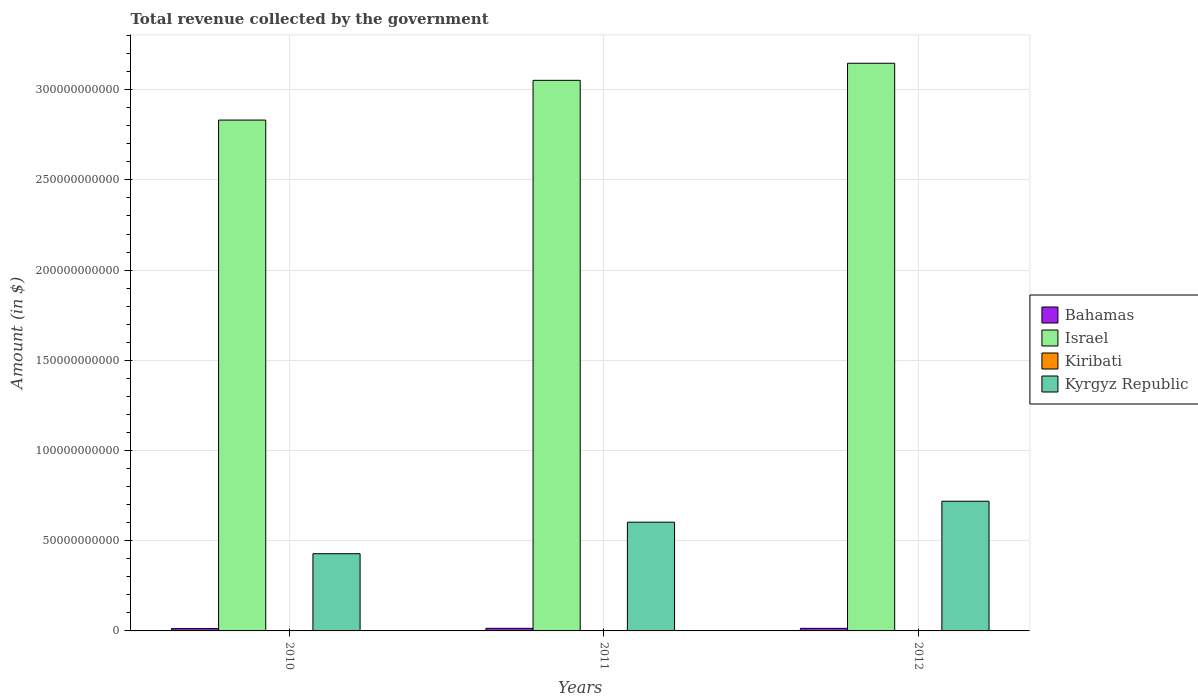How many different coloured bars are there?
Your answer should be compact. 4. Are the number of bars on each tick of the X-axis equal?
Provide a succinct answer. Yes. How many bars are there on the 3rd tick from the right?
Your response must be concise. 4. What is the label of the 1st group of bars from the left?
Your answer should be compact. 2010. In how many cases, is the number of bars for a given year not equal to the number of legend labels?
Offer a very short reply. 0. What is the total revenue collected by the government in Israel in 2010?
Ensure brevity in your answer.  2.83e+11. Across all years, what is the maximum total revenue collected by the government in Bahamas?
Provide a succinct answer. 1.43e+09. Across all years, what is the minimum total revenue collected by the government in Bahamas?
Keep it short and to the point. 1.29e+09. What is the total total revenue collected by the government in Bahamas in the graph?
Offer a terse response. 4.15e+09. What is the difference between the total revenue collected by the government in Kyrgyz Republic in 2011 and that in 2012?
Provide a short and direct response. -1.16e+1. What is the difference between the total revenue collected by the government in Israel in 2011 and the total revenue collected by the government in Bahamas in 2012?
Give a very brief answer. 3.04e+11. What is the average total revenue collected by the government in Kiribati per year?
Ensure brevity in your answer.  9.79e+07. In the year 2010, what is the difference between the total revenue collected by the government in Israel and total revenue collected by the government in Bahamas?
Your response must be concise. 2.82e+11. What is the ratio of the total revenue collected by the government in Kiribati in 2011 to that in 2012?
Give a very brief answer. 0.76. Is the total revenue collected by the government in Kiribati in 2010 less than that in 2012?
Ensure brevity in your answer.  Yes. Is the difference between the total revenue collected by the government in Israel in 2011 and 2012 greater than the difference between the total revenue collected by the government in Bahamas in 2011 and 2012?
Make the answer very short. No. What is the difference between the highest and the second highest total revenue collected by the government in Kyrgyz Republic?
Keep it short and to the point. 1.16e+1. What is the difference between the highest and the lowest total revenue collected by the government in Israel?
Give a very brief answer. 3.15e+1. In how many years, is the total revenue collected by the government in Kiribati greater than the average total revenue collected by the government in Kiribati taken over all years?
Your answer should be very brief. 1. What does the 2nd bar from the left in 2012 represents?
Give a very brief answer. Israel. Is it the case that in every year, the sum of the total revenue collected by the government in Kyrgyz Republic and total revenue collected by the government in Kiribati is greater than the total revenue collected by the government in Bahamas?
Give a very brief answer. Yes. How many bars are there?
Give a very brief answer. 12. What is the difference between two consecutive major ticks on the Y-axis?
Give a very brief answer. 5.00e+1. Are the values on the major ticks of Y-axis written in scientific E-notation?
Your answer should be very brief. No. Does the graph contain any zero values?
Your answer should be compact. No. How many legend labels are there?
Give a very brief answer. 4. How are the legend labels stacked?
Provide a succinct answer. Vertical. What is the title of the graph?
Provide a short and direct response. Total revenue collected by the government. What is the label or title of the Y-axis?
Give a very brief answer. Amount (in $). What is the Amount (in $) of Bahamas in 2010?
Provide a short and direct response. 1.29e+09. What is the Amount (in $) of Israel in 2010?
Provide a short and direct response. 2.83e+11. What is the Amount (in $) in Kiribati in 2010?
Your answer should be compact. 9.63e+07. What is the Amount (in $) of Kyrgyz Republic in 2010?
Give a very brief answer. 4.28e+1. What is the Amount (in $) in Bahamas in 2011?
Give a very brief answer. 1.43e+09. What is the Amount (in $) in Israel in 2011?
Make the answer very short. 3.05e+11. What is the Amount (in $) in Kiribati in 2011?
Ensure brevity in your answer.  8.50e+07. What is the Amount (in $) of Kyrgyz Republic in 2011?
Keep it short and to the point. 6.03e+1. What is the Amount (in $) in Bahamas in 2012?
Ensure brevity in your answer.  1.43e+09. What is the Amount (in $) of Israel in 2012?
Give a very brief answer. 3.15e+11. What is the Amount (in $) in Kiribati in 2012?
Make the answer very short. 1.12e+08. What is the Amount (in $) in Kyrgyz Republic in 2012?
Ensure brevity in your answer.  7.19e+1. Across all years, what is the maximum Amount (in $) of Bahamas?
Your response must be concise. 1.43e+09. Across all years, what is the maximum Amount (in $) of Israel?
Your answer should be compact. 3.15e+11. Across all years, what is the maximum Amount (in $) in Kiribati?
Offer a very short reply. 1.12e+08. Across all years, what is the maximum Amount (in $) in Kyrgyz Republic?
Your answer should be very brief. 7.19e+1. Across all years, what is the minimum Amount (in $) in Bahamas?
Provide a succinct answer. 1.29e+09. Across all years, what is the minimum Amount (in $) of Israel?
Make the answer very short. 2.83e+11. Across all years, what is the minimum Amount (in $) in Kiribati?
Your answer should be compact. 8.50e+07. Across all years, what is the minimum Amount (in $) in Kyrgyz Republic?
Offer a terse response. 4.28e+1. What is the total Amount (in $) in Bahamas in the graph?
Give a very brief answer. 4.15e+09. What is the total Amount (in $) in Israel in the graph?
Offer a very short reply. 9.03e+11. What is the total Amount (in $) in Kiribati in the graph?
Make the answer very short. 2.94e+08. What is the total Amount (in $) in Kyrgyz Republic in the graph?
Provide a succinct answer. 1.75e+11. What is the difference between the Amount (in $) in Bahamas in 2010 and that in 2011?
Give a very brief answer. -1.41e+08. What is the difference between the Amount (in $) in Israel in 2010 and that in 2011?
Your response must be concise. -2.20e+1. What is the difference between the Amount (in $) of Kiribati in 2010 and that in 2011?
Your answer should be very brief. 1.13e+07. What is the difference between the Amount (in $) in Kyrgyz Republic in 2010 and that in 2011?
Provide a succinct answer. -1.75e+1. What is the difference between the Amount (in $) of Bahamas in 2010 and that in 2012?
Provide a succinct answer. -1.35e+08. What is the difference between the Amount (in $) in Israel in 2010 and that in 2012?
Offer a terse response. -3.15e+1. What is the difference between the Amount (in $) of Kiribati in 2010 and that in 2012?
Give a very brief answer. -1.61e+07. What is the difference between the Amount (in $) in Kyrgyz Republic in 2010 and that in 2012?
Ensure brevity in your answer.  -2.91e+1. What is the difference between the Amount (in $) of Bahamas in 2011 and that in 2012?
Offer a terse response. 6.14e+06. What is the difference between the Amount (in $) in Israel in 2011 and that in 2012?
Ensure brevity in your answer.  -9.46e+09. What is the difference between the Amount (in $) in Kiribati in 2011 and that in 2012?
Your answer should be very brief. -2.74e+07. What is the difference between the Amount (in $) in Kyrgyz Republic in 2011 and that in 2012?
Give a very brief answer. -1.16e+1. What is the difference between the Amount (in $) in Bahamas in 2010 and the Amount (in $) in Israel in 2011?
Ensure brevity in your answer.  -3.04e+11. What is the difference between the Amount (in $) of Bahamas in 2010 and the Amount (in $) of Kiribati in 2011?
Your answer should be very brief. 1.21e+09. What is the difference between the Amount (in $) in Bahamas in 2010 and the Amount (in $) in Kyrgyz Republic in 2011?
Provide a succinct answer. -5.90e+1. What is the difference between the Amount (in $) of Israel in 2010 and the Amount (in $) of Kiribati in 2011?
Your answer should be compact. 2.83e+11. What is the difference between the Amount (in $) in Israel in 2010 and the Amount (in $) in Kyrgyz Republic in 2011?
Offer a terse response. 2.23e+11. What is the difference between the Amount (in $) of Kiribati in 2010 and the Amount (in $) of Kyrgyz Republic in 2011?
Offer a very short reply. -6.02e+1. What is the difference between the Amount (in $) in Bahamas in 2010 and the Amount (in $) in Israel in 2012?
Your answer should be compact. -3.13e+11. What is the difference between the Amount (in $) in Bahamas in 2010 and the Amount (in $) in Kiribati in 2012?
Give a very brief answer. 1.18e+09. What is the difference between the Amount (in $) of Bahamas in 2010 and the Amount (in $) of Kyrgyz Republic in 2012?
Your answer should be very brief. -7.06e+1. What is the difference between the Amount (in $) in Israel in 2010 and the Amount (in $) in Kiribati in 2012?
Offer a terse response. 2.83e+11. What is the difference between the Amount (in $) in Israel in 2010 and the Amount (in $) in Kyrgyz Republic in 2012?
Your answer should be very brief. 2.11e+11. What is the difference between the Amount (in $) of Kiribati in 2010 and the Amount (in $) of Kyrgyz Republic in 2012?
Offer a very short reply. -7.18e+1. What is the difference between the Amount (in $) of Bahamas in 2011 and the Amount (in $) of Israel in 2012?
Provide a succinct answer. -3.13e+11. What is the difference between the Amount (in $) in Bahamas in 2011 and the Amount (in $) in Kiribati in 2012?
Ensure brevity in your answer.  1.32e+09. What is the difference between the Amount (in $) of Bahamas in 2011 and the Amount (in $) of Kyrgyz Republic in 2012?
Your response must be concise. -7.05e+1. What is the difference between the Amount (in $) in Israel in 2011 and the Amount (in $) in Kiribati in 2012?
Keep it short and to the point. 3.05e+11. What is the difference between the Amount (in $) in Israel in 2011 and the Amount (in $) in Kyrgyz Republic in 2012?
Make the answer very short. 2.33e+11. What is the difference between the Amount (in $) of Kiribati in 2011 and the Amount (in $) of Kyrgyz Republic in 2012?
Keep it short and to the point. -7.18e+1. What is the average Amount (in $) in Bahamas per year?
Make the answer very short. 1.38e+09. What is the average Amount (in $) of Israel per year?
Your answer should be very brief. 3.01e+11. What is the average Amount (in $) of Kiribati per year?
Offer a terse response. 9.79e+07. What is the average Amount (in $) of Kyrgyz Republic per year?
Provide a succinct answer. 5.83e+1. In the year 2010, what is the difference between the Amount (in $) of Bahamas and Amount (in $) of Israel?
Ensure brevity in your answer.  -2.82e+11. In the year 2010, what is the difference between the Amount (in $) in Bahamas and Amount (in $) in Kiribati?
Ensure brevity in your answer.  1.19e+09. In the year 2010, what is the difference between the Amount (in $) of Bahamas and Amount (in $) of Kyrgyz Republic?
Offer a very short reply. -4.15e+1. In the year 2010, what is the difference between the Amount (in $) in Israel and Amount (in $) in Kiribati?
Make the answer very short. 2.83e+11. In the year 2010, what is the difference between the Amount (in $) in Israel and Amount (in $) in Kyrgyz Republic?
Your answer should be very brief. 2.40e+11. In the year 2010, what is the difference between the Amount (in $) of Kiribati and Amount (in $) of Kyrgyz Republic?
Ensure brevity in your answer.  -4.27e+1. In the year 2011, what is the difference between the Amount (in $) in Bahamas and Amount (in $) in Israel?
Offer a terse response. -3.04e+11. In the year 2011, what is the difference between the Amount (in $) of Bahamas and Amount (in $) of Kiribati?
Provide a short and direct response. 1.35e+09. In the year 2011, what is the difference between the Amount (in $) of Bahamas and Amount (in $) of Kyrgyz Republic?
Your answer should be compact. -5.88e+1. In the year 2011, what is the difference between the Amount (in $) of Israel and Amount (in $) of Kiribati?
Provide a short and direct response. 3.05e+11. In the year 2011, what is the difference between the Amount (in $) of Israel and Amount (in $) of Kyrgyz Republic?
Your answer should be very brief. 2.45e+11. In the year 2011, what is the difference between the Amount (in $) of Kiribati and Amount (in $) of Kyrgyz Republic?
Your answer should be very brief. -6.02e+1. In the year 2012, what is the difference between the Amount (in $) of Bahamas and Amount (in $) of Israel?
Keep it short and to the point. -3.13e+11. In the year 2012, what is the difference between the Amount (in $) of Bahamas and Amount (in $) of Kiribati?
Provide a succinct answer. 1.31e+09. In the year 2012, what is the difference between the Amount (in $) of Bahamas and Amount (in $) of Kyrgyz Republic?
Provide a short and direct response. -7.05e+1. In the year 2012, what is the difference between the Amount (in $) in Israel and Amount (in $) in Kiribati?
Your answer should be compact. 3.15e+11. In the year 2012, what is the difference between the Amount (in $) in Israel and Amount (in $) in Kyrgyz Republic?
Offer a very short reply. 2.43e+11. In the year 2012, what is the difference between the Amount (in $) of Kiribati and Amount (in $) of Kyrgyz Republic?
Offer a very short reply. -7.18e+1. What is the ratio of the Amount (in $) of Bahamas in 2010 to that in 2011?
Offer a very short reply. 0.9. What is the ratio of the Amount (in $) in Israel in 2010 to that in 2011?
Make the answer very short. 0.93. What is the ratio of the Amount (in $) in Kiribati in 2010 to that in 2011?
Give a very brief answer. 1.13. What is the ratio of the Amount (in $) of Kyrgyz Republic in 2010 to that in 2011?
Provide a succinct answer. 0.71. What is the ratio of the Amount (in $) of Bahamas in 2010 to that in 2012?
Provide a succinct answer. 0.91. What is the ratio of the Amount (in $) in Israel in 2010 to that in 2012?
Your answer should be compact. 0.9. What is the ratio of the Amount (in $) in Kiribati in 2010 to that in 2012?
Provide a succinct answer. 0.86. What is the ratio of the Amount (in $) of Kyrgyz Republic in 2010 to that in 2012?
Provide a short and direct response. 0.6. What is the ratio of the Amount (in $) in Bahamas in 2011 to that in 2012?
Keep it short and to the point. 1. What is the ratio of the Amount (in $) in Israel in 2011 to that in 2012?
Make the answer very short. 0.97. What is the ratio of the Amount (in $) in Kiribati in 2011 to that in 2012?
Give a very brief answer. 0.76. What is the ratio of the Amount (in $) of Kyrgyz Republic in 2011 to that in 2012?
Your response must be concise. 0.84. What is the difference between the highest and the second highest Amount (in $) in Bahamas?
Keep it short and to the point. 6.14e+06. What is the difference between the highest and the second highest Amount (in $) in Israel?
Your response must be concise. 9.46e+09. What is the difference between the highest and the second highest Amount (in $) of Kiribati?
Your answer should be very brief. 1.61e+07. What is the difference between the highest and the second highest Amount (in $) of Kyrgyz Republic?
Make the answer very short. 1.16e+1. What is the difference between the highest and the lowest Amount (in $) in Bahamas?
Your response must be concise. 1.41e+08. What is the difference between the highest and the lowest Amount (in $) of Israel?
Give a very brief answer. 3.15e+1. What is the difference between the highest and the lowest Amount (in $) in Kiribati?
Provide a succinct answer. 2.74e+07. What is the difference between the highest and the lowest Amount (in $) in Kyrgyz Republic?
Your response must be concise. 2.91e+1. 